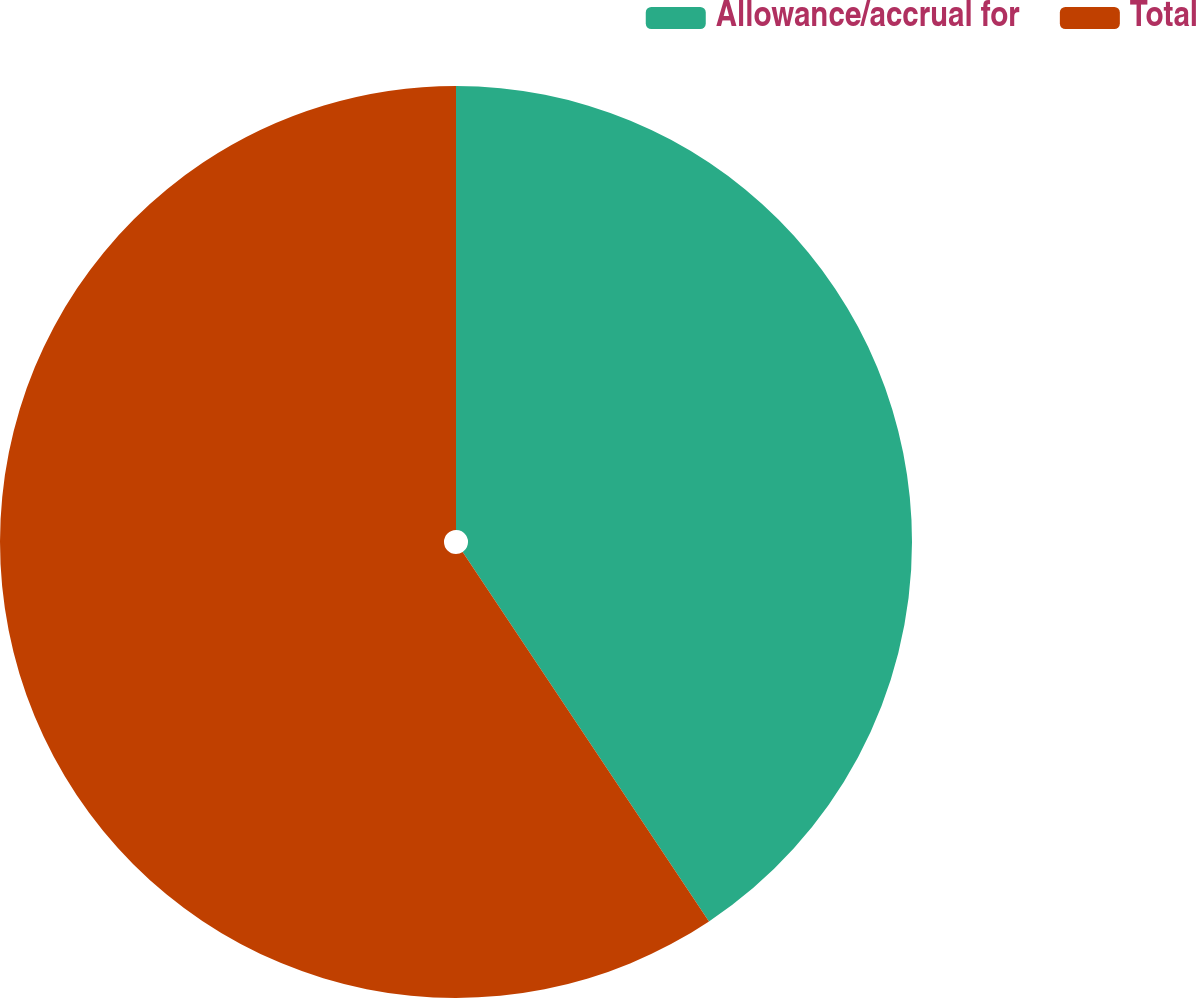Convert chart to OTSL. <chart><loc_0><loc_0><loc_500><loc_500><pie_chart><fcel>Allowance/accrual for<fcel>Total<nl><fcel>40.64%<fcel>59.36%<nl></chart> 